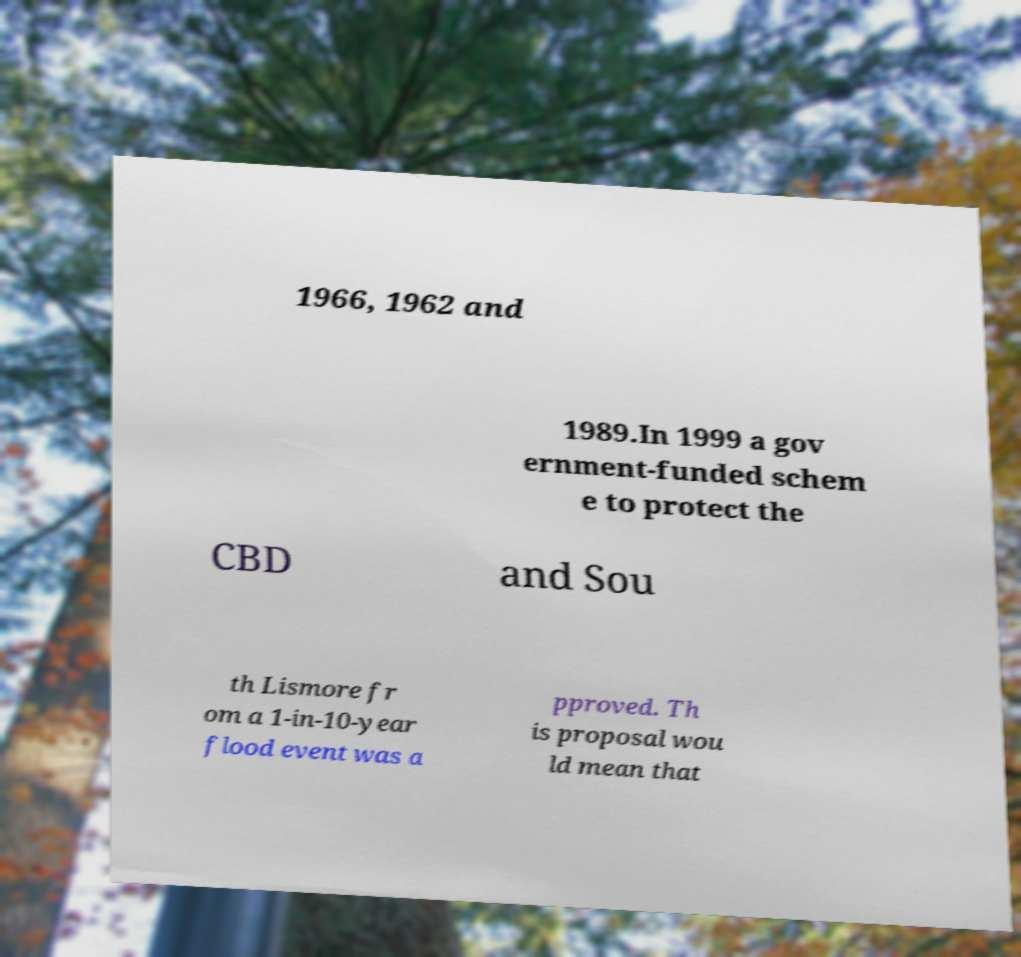Could you extract and type out the text from this image? 1966, 1962 and 1989.In 1999 a gov ernment-funded schem e to protect the CBD and Sou th Lismore fr om a 1-in-10-year flood event was a pproved. Th is proposal wou ld mean that 